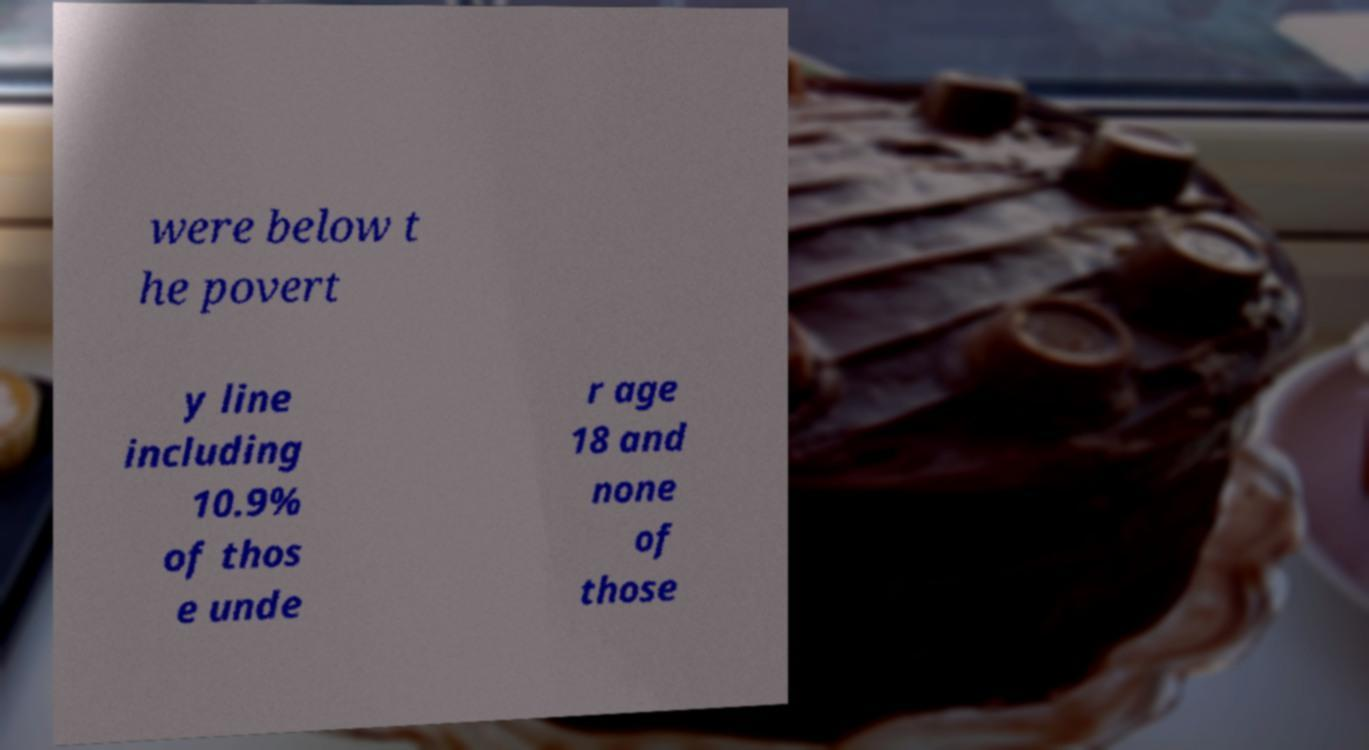Could you extract and type out the text from this image? were below t he povert y line including 10.9% of thos e unde r age 18 and none of those 